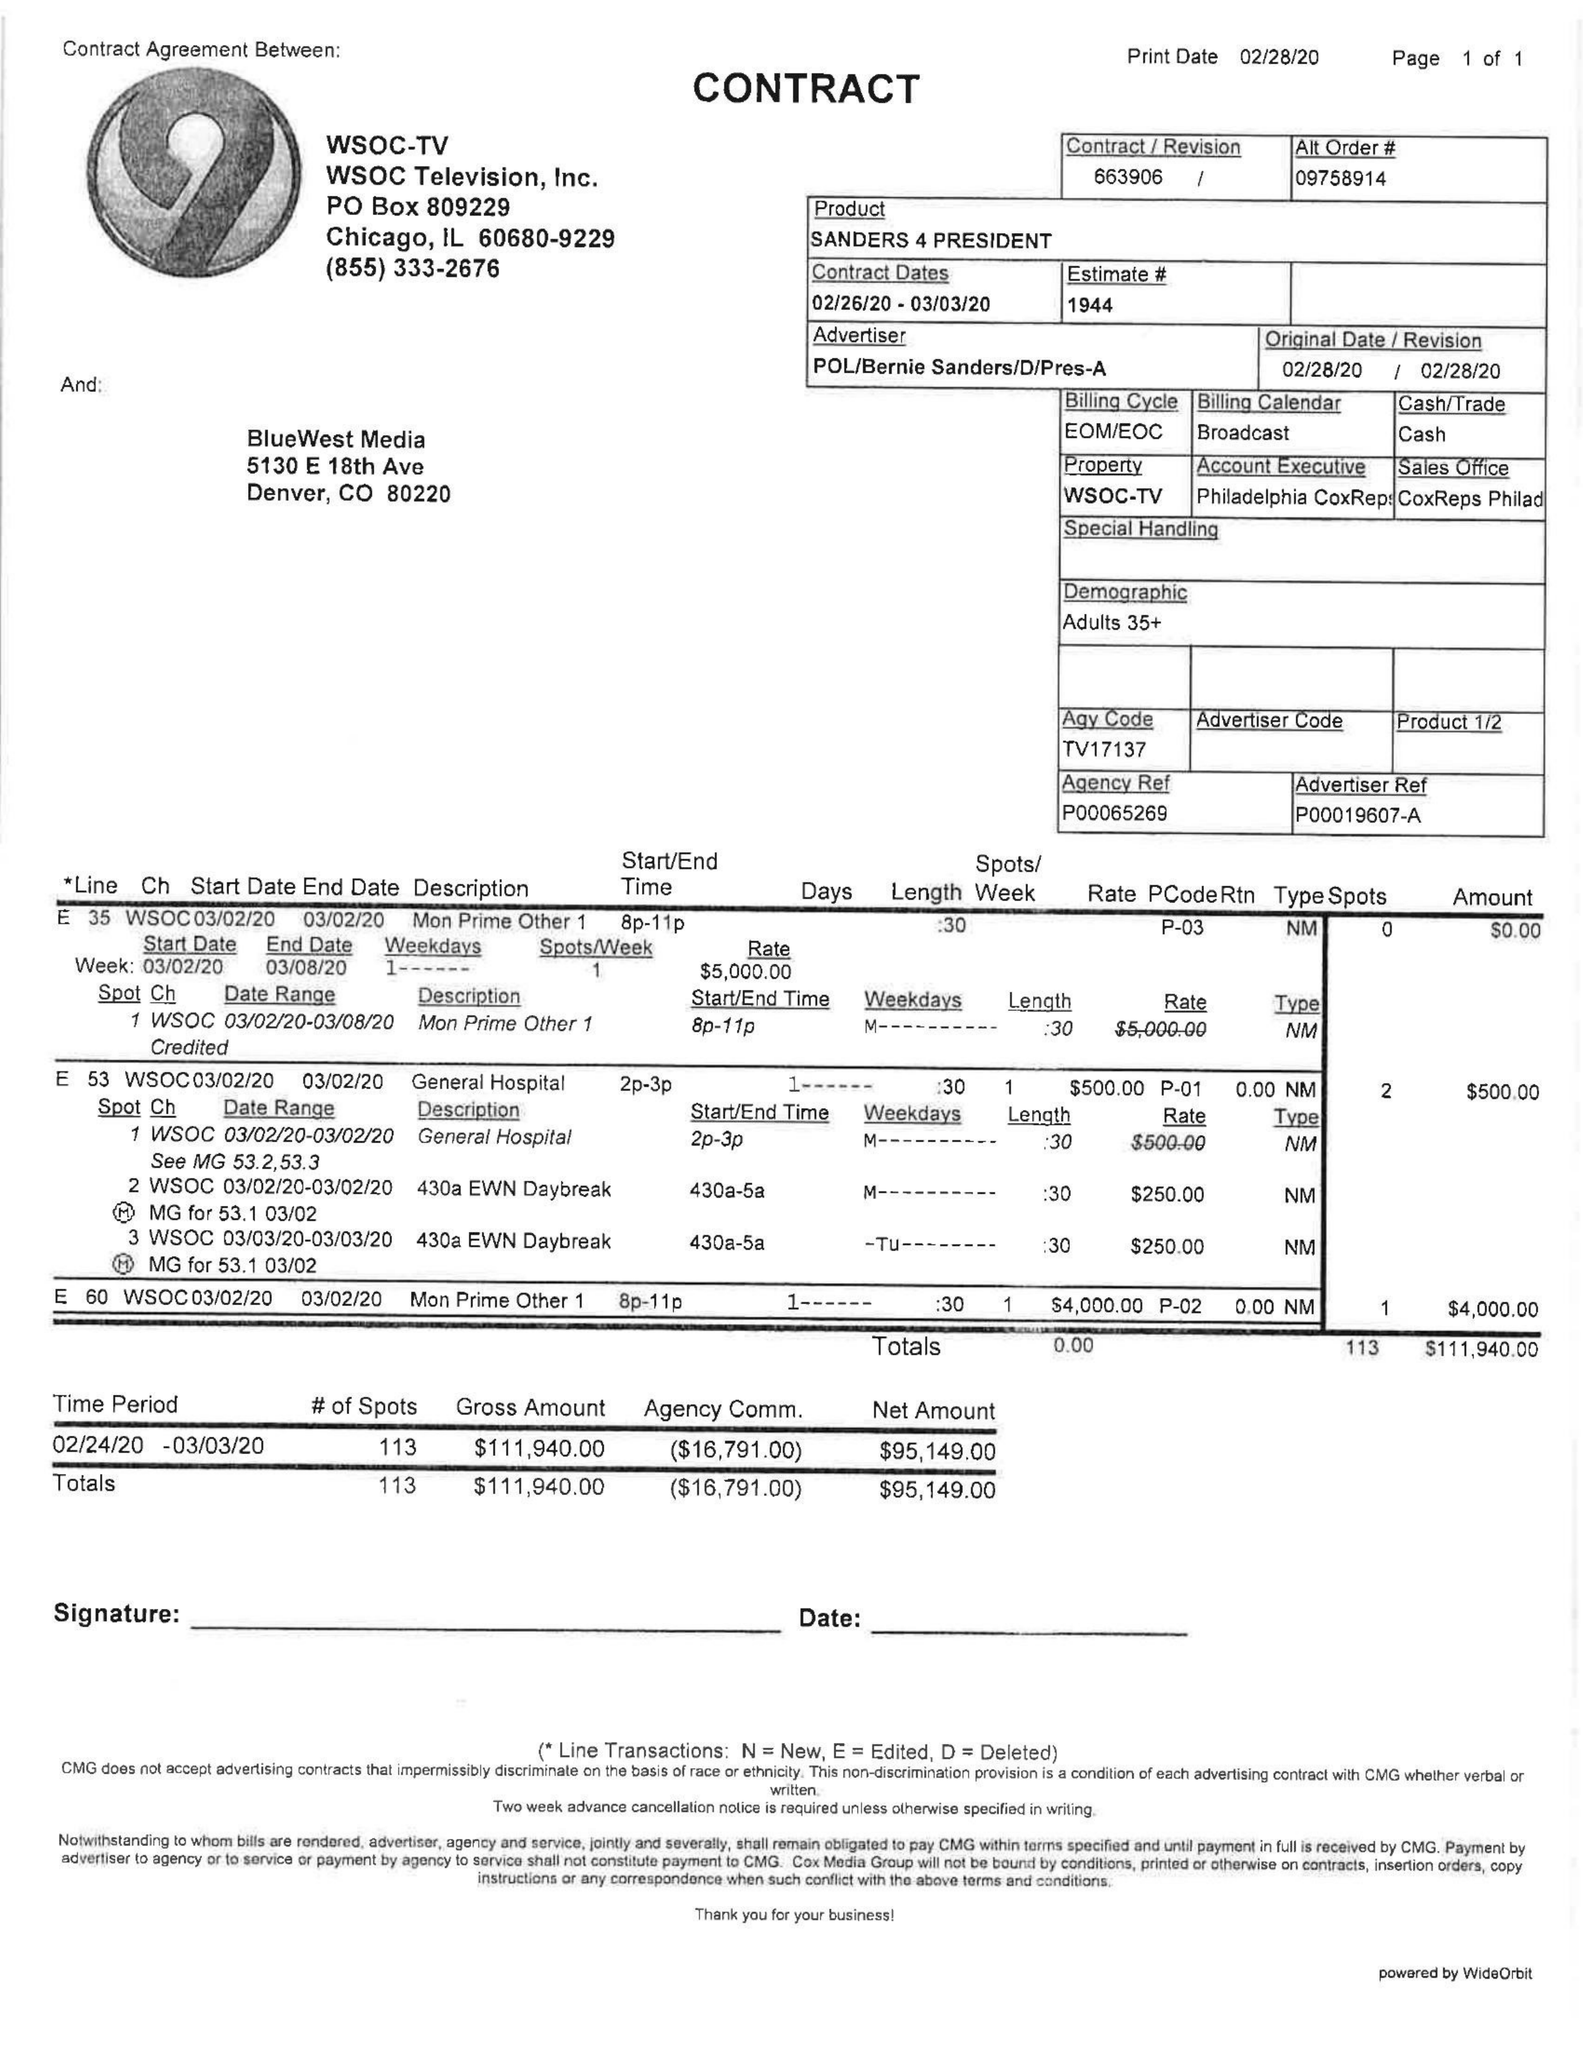What is the value for the contract_num?
Answer the question using a single word or phrase. 663906 